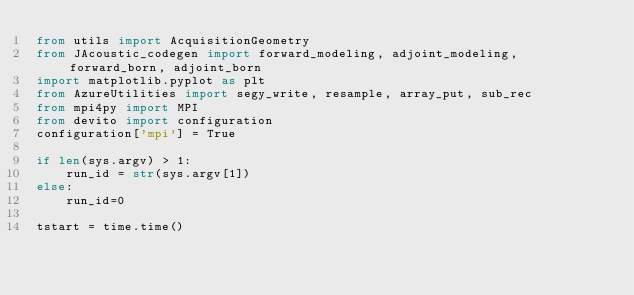<code> <loc_0><loc_0><loc_500><loc_500><_Python_>from utils import AcquisitionGeometry
from JAcoustic_codegen import forward_modeling, adjoint_modeling, forward_born, adjoint_born
import matplotlib.pyplot as plt
from AzureUtilities import segy_write, resample, array_put, sub_rec
from mpi4py import MPI
from devito import configuration
configuration['mpi'] = True

if len(sys.argv) > 1:
    run_id = str(sys.argv[1])
else:
    run_id=0

tstart = time.time()
</code> 